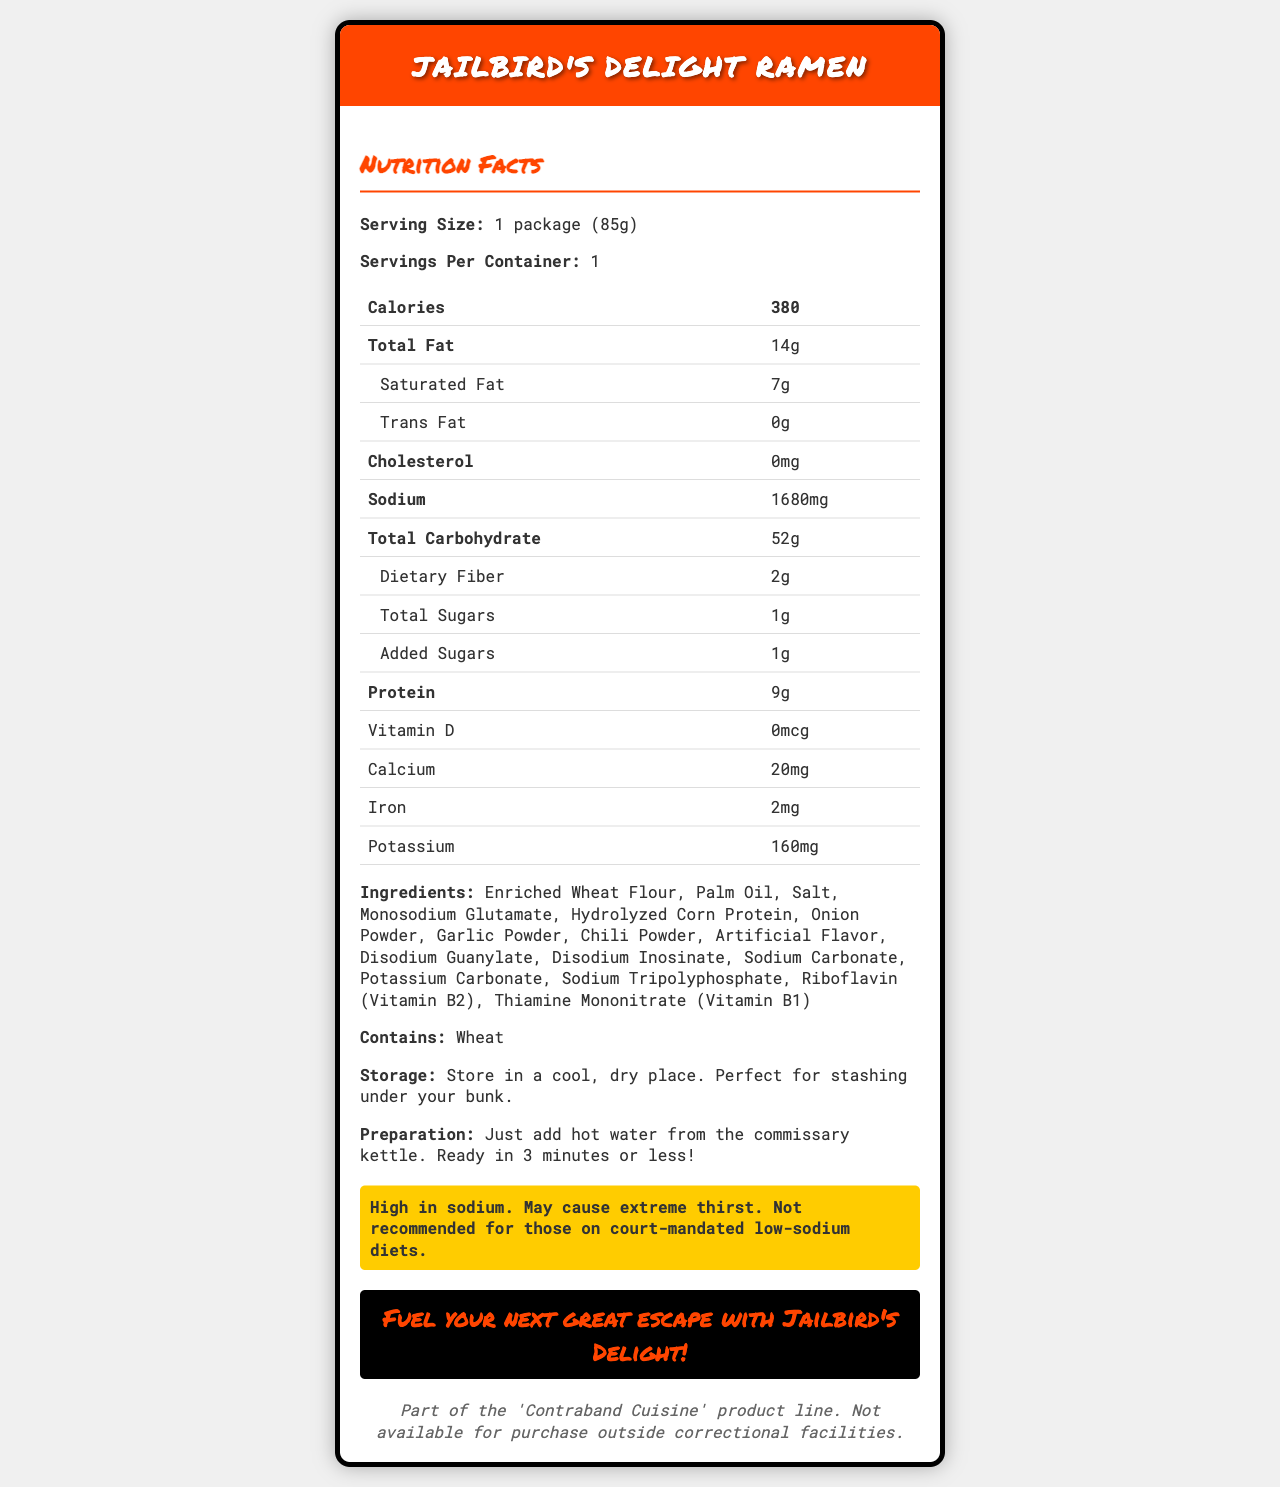who should avoid eating Jailbird's Delight Ramen? The warning section of the label advises that it is not recommended for those on court-mandated low-sodium diets due to its high sodium content.
Answer: Those on court-mandated low-sodium diets how much sodium does one package contain? The nutrition facts section lists the sodium content as 1680 mg.
Answer: 1680 mg what is the serving size for Jailbird's Delight Ramen? The serving size is provided at the beginning of the nutrition facts section.
Answer: 1 package (85g) how long does it take to prepare the ramen? The preparation instructions state that it is ready in 3 minutes or less.
Answer: 3 minutes or less how many grams of saturated fat are in a serving? The nutrition facts section indicates that there are 7 grams of saturated fat per serving.
Answer: 7 grams does the ramen contain any artificial flavors? The ingredients list mentions artificial flavor.
Answer: Yes what is the storage recommendation for the ramen? The storage instructions specify to store in a cool, dry place.
Answer: Store in a cool, dry place what vitamin content is specified in the nutrition label? A. Vitamin A B. Vitamin B6 C. Vitamin D Vitamin D is listed in the nutrition facts section, while Vitamin A and Vitamin B6 are not mentioned.
Answer: C. Vitamin D how many grams of protein are in one package? A. 7 grams B. 8 grams C. 9 grams D. 10 grams The nutrition facts section indicates that there are 9 grams of protein in one package.
Answer: C. 9 grams does Jailbird's Delight Ramen contain wheat? The allergens information lists wheat as an allergen.
Answer: Yes do the noodles contain any cholesterol? The nutrition facts section indicates that the cholesterol content is zero.
Answer: No summarize the main idea of the document. The document provides comprehensive information about Jailbird's Delight Ramen, including nutrition facts, ingredients, allergens, storage and preparation instructions, and a warning about its high sodium content. It is evidently marketed specifically for correctional facility use.
Answer: Jailbird's Delight Ramen is a high-sodium instant noodle product with a witty marketing angle designed for correctional facility use. It contains a substantial amount of fat, carbohydrates, and protein, with detailed instructions for storage and preparation. how much iron does one package of the ramen provide? The nutrition facts section lists the iron content as 2 mg.
Answer: 2 mg what is the slogan for Jailbird's Delight Ramen? The marketing slogan is given in the document.
Answer: Fuel your next great escape with Jailbird's Delight! how many servings per container are available? The nutrition facts section states that there is 1 serving per container.
Answer: 1 what is the main ingredient listed first in Jailbird's Delight Ramen? The first item in the ingredients list is Enriched Wheat Flour.
Answer: Enriched Wheat Flour what is the total carbohydrate content in one serving? The nutrition facts section lists the total carbohydrate content as 52 grams.
Answer: 52 grams what is the primary use suggested by the storage recommendation? The storage instructions humorously suggest stashing under your bunk, implying its intended use within correctional facilities.
Answer: Stashing under your bunk what is the calcium content for this product? The nutrition facts section states that the calcium content is 20 mg.
Answer: 20 mg how much added sugar is in one serving? The nutrition facts section indicates there is 1 gram of added sugars per serving.
Answer: 1 gram what other nutrients are enriched in Jailbird's Delight Ramen? These vitamins are listed as part of the ingredients.
Answer: Riboflavin (Vitamin B2) and Thiamine Mononitrate (Vitamin B1) what is the color of the warning background on the label? The color of the warning background is not explicitly mentioned in the textual data provided, although it is likely yellow based on color conventions used in warnings.
Answer: Cannot be determined what product line is Jailbird's Delight Ramen part of? The additional info section states that it is part of the 'Contraband Cuisine' product line.
Answer: Contraband Cuisine 